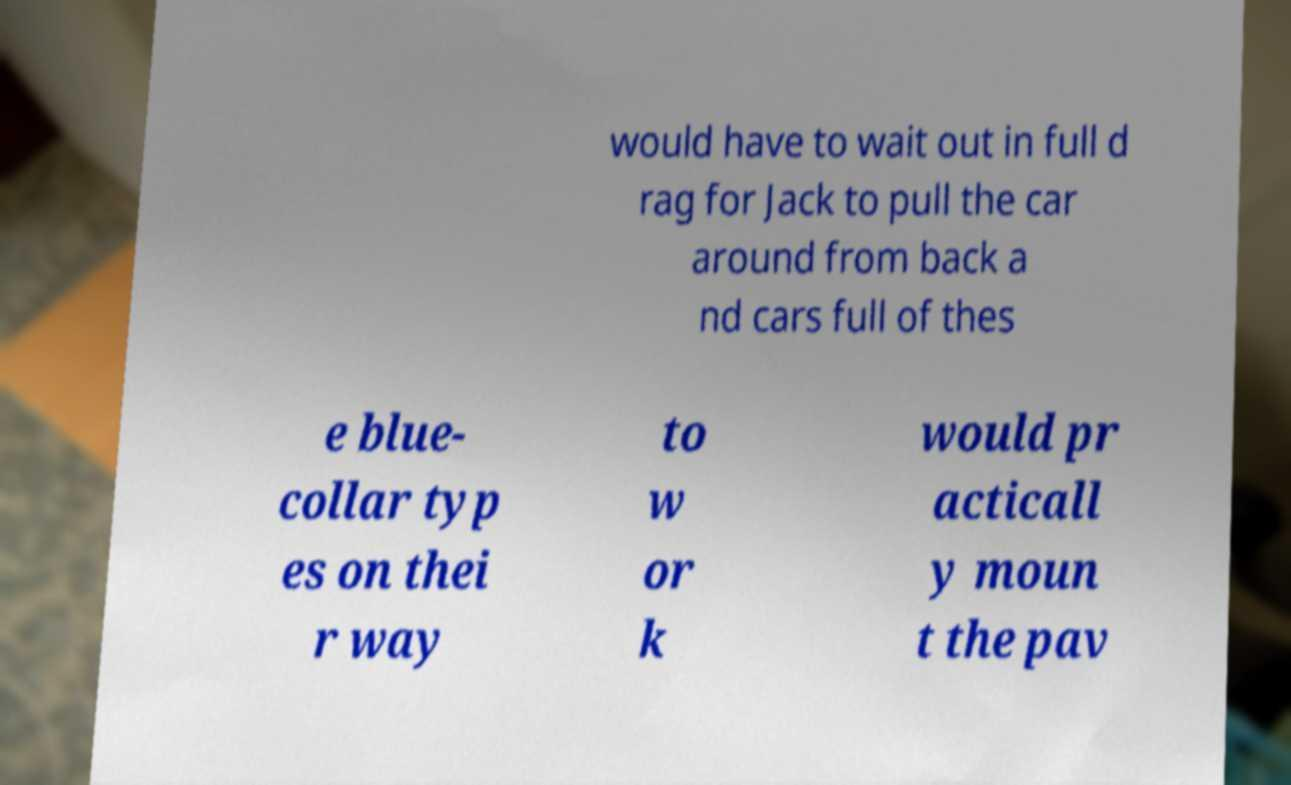Please read and relay the text visible in this image. What does it say? would have to wait out in full d rag for Jack to pull the car around from back a nd cars full of thes e blue- collar typ es on thei r way to w or k would pr acticall y moun t the pav 